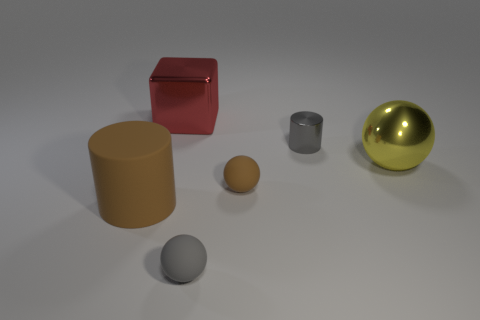Subtract all small gray spheres. How many spheres are left? 2 Add 3 small cyan balls. How many objects exist? 9 Subtract all cubes. How many objects are left? 5 Subtract all yellow spheres. How many spheres are left? 2 Subtract all yellow blocks. Subtract all yellow balls. How many blocks are left? 1 Subtract all cylinders. Subtract all brown matte spheres. How many objects are left? 3 Add 1 yellow metallic things. How many yellow metallic things are left? 2 Add 2 balls. How many balls exist? 5 Subtract 0 green balls. How many objects are left? 6 Subtract 1 balls. How many balls are left? 2 